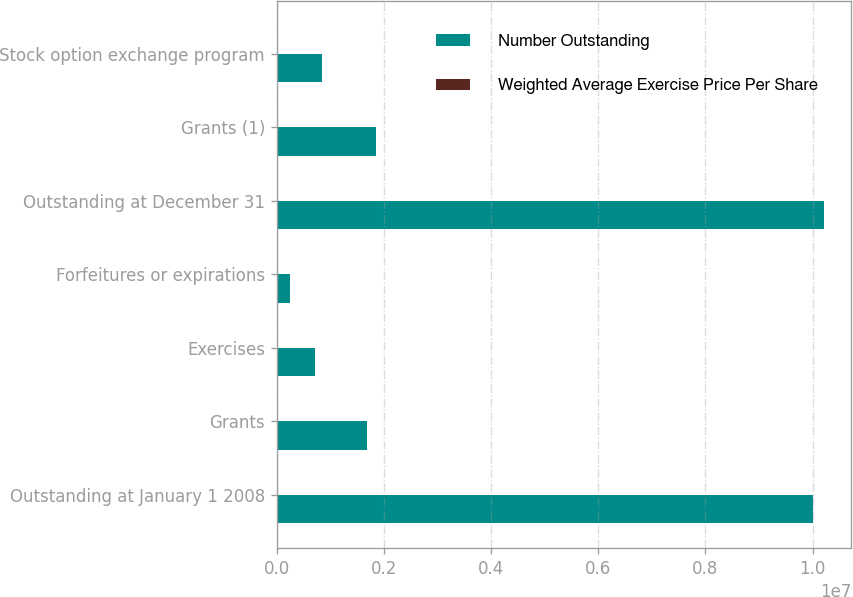<chart> <loc_0><loc_0><loc_500><loc_500><stacked_bar_chart><ecel><fcel>Outstanding at January 1 2008<fcel>Grants<fcel>Exercises<fcel>Forfeitures or expirations<fcel>Outstanding at December 31<fcel>Grants (1)<fcel>Stock option exchange program<nl><fcel>Number Outstanding<fcel>9.99811e+06<fcel>1.68684e+06<fcel>712860<fcel>245188<fcel>1.02069e+07<fcel>1.85598e+06<fcel>846129<nl><fcel>Weighted Average Exercise Price Per Share<fcel>16.25<fcel>27.48<fcel>8.96<fcel>31.43<fcel>18.18<fcel>19.87<fcel>38.96<nl></chart> 